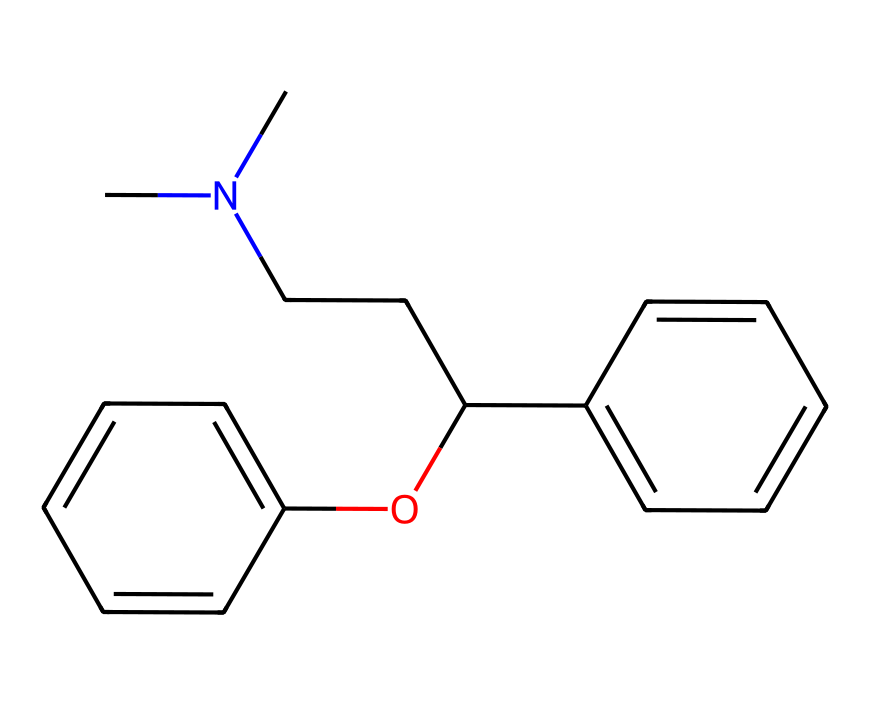What is the chemical name of this compound? By looking at the structure, it is identifiable as diphenhydramine because of its common usage as an antihistamine and its specific arrangement of atoms seen in the SMILES notation.
Answer: diphenhydramine How many carbon atoms are present in the structure? Analyzing the SMILES representation, we can count the carbon atoms represented by 'C' and any part of the structure containing carbon, yielding a total of 20 carbon atoms.
Answer: 20 Does this compound contain any nitrogen atoms? In the given SMILES representation, we observe the presence of the symbol 'N', which indicates that there is one nitrogen atom in the structure.
Answer: yes What is the number of hydroxyl (OH) groups in this compound? The 'O' in the structure denotes a hydroxyl group attached to a carbon chain, and upon examining the SMILES, we find that there is a single hydroxyl (OH) group in the compound.
Answer: 1 What type of bonding is predominant in this compound? The presence of carbon-carbon (C-C) and carbon-hydrogen (C-H) single bonds, along with some aromatic rings indicates that covalent bonding is predominant in this compound's structure.
Answer: covalent How many aromatic rings are present in the molecule? Analyzing the structure, we notice two distinct aromatic rings in the SMILES representation (C1=CC=CC=C1 and C2=CC=CC=C2), leading us to conclude that there are two aromatic rings.
Answer: 2 What configuration in the structure allows diphenhydramine to act as an antihistamine? The presence of the nitrogen atom within the connecting chain of a branched alkyl group is crucial, as it forms a structure that can effectively block histamine receptors, characteristic of antihistamines.
Answer: nitrogen atom 